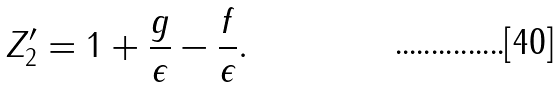Convert formula to latex. <formula><loc_0><loc_0><loc_500><loc_500>Z _ { 2 } ^ { \prime } = 1 + \frac { g } { \epsilon } - \frac { f } { \epsilon } .</formula> 